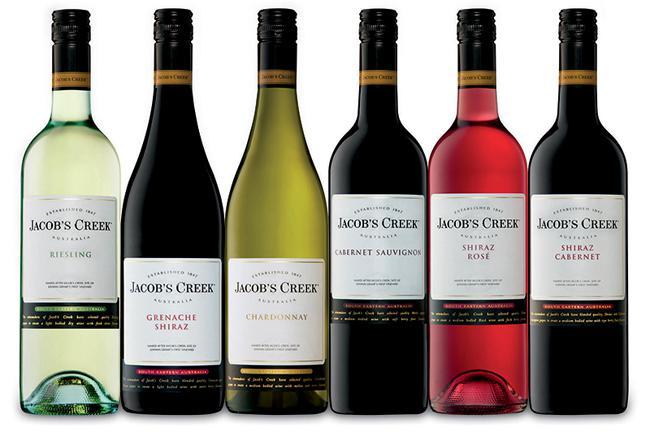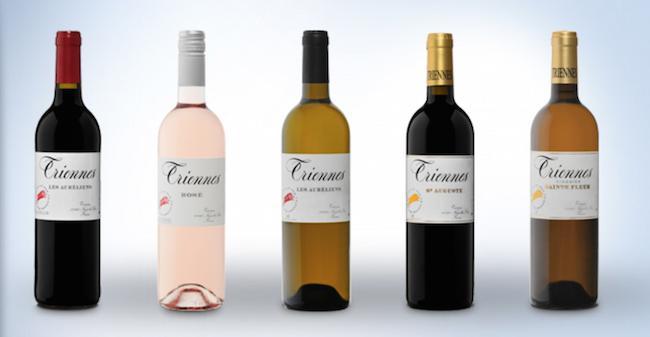The first image is the image on the left, the second image is the image on the right. Analyze the images presented: Is the assertion "One of these images contains exactly four wine bottles." valid? Answer yes or no. No. The first image is the image on the left, the second image is the image on the right. Examine the images to the left and right. Is the description "There are no more than five wine bottles in the left image." accurate? Answer yes or no. No. 